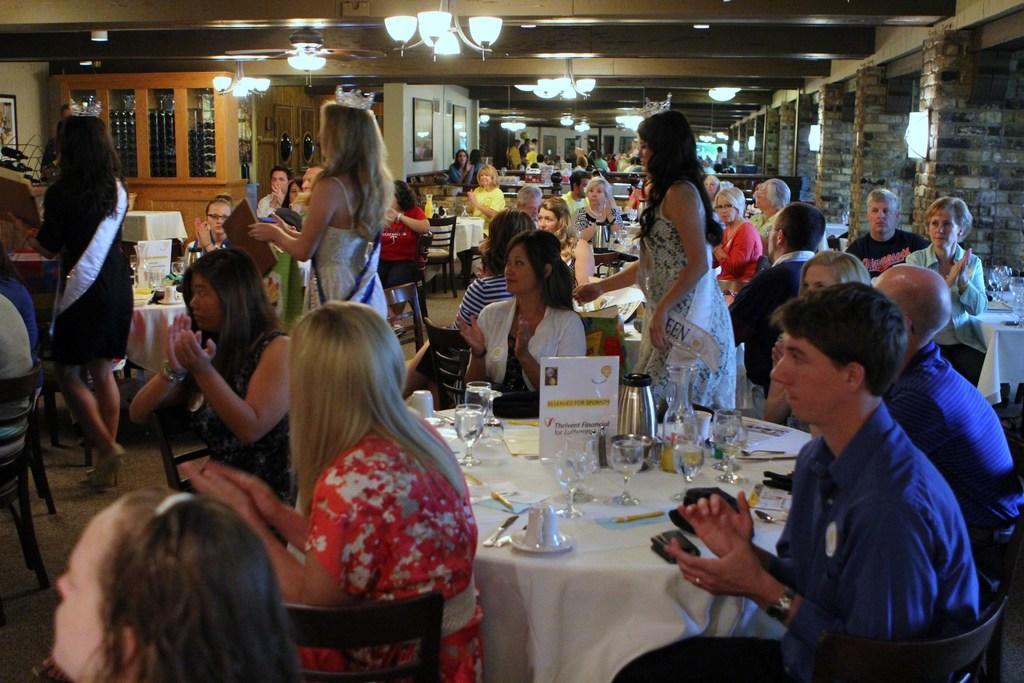Please provide a concise description of this image. There are many people. Some are standing and some are sitting on chairs. There are tables. On the table there are glasses, cups, saucers, jug and many other items. On the ceiling there are lights. In the back there are glass windows. Also there are photo frames on the wall. And there are brick walls. 